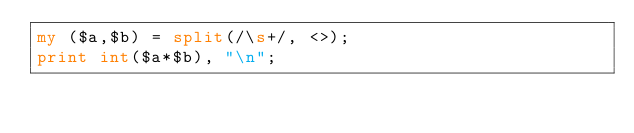<code> <loc_0><loc_0><loc_500><loc_500><_Perl_>my ($a,$b) = split(/\s+/, <>);
print int($a*$b), "\n";
</code> 